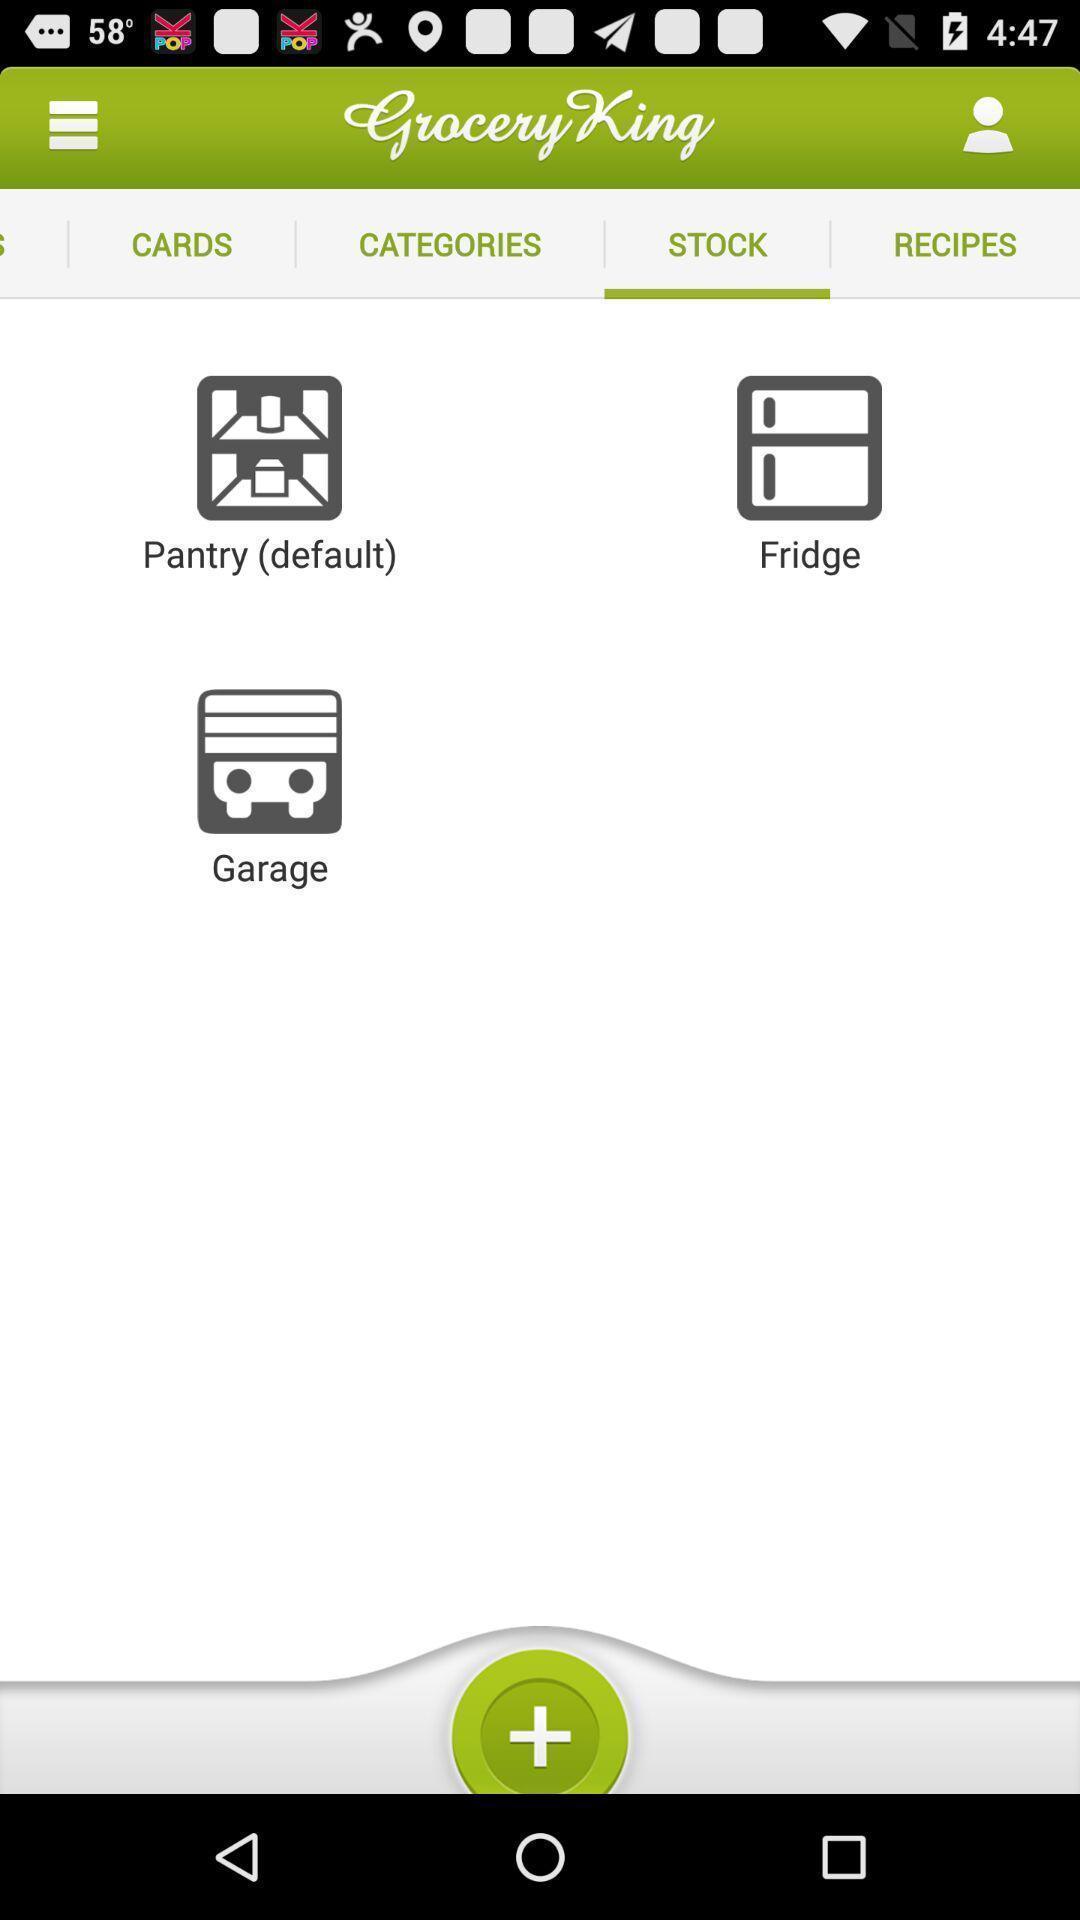Summarize the main components in this picture. Page showing stock on groceries. 